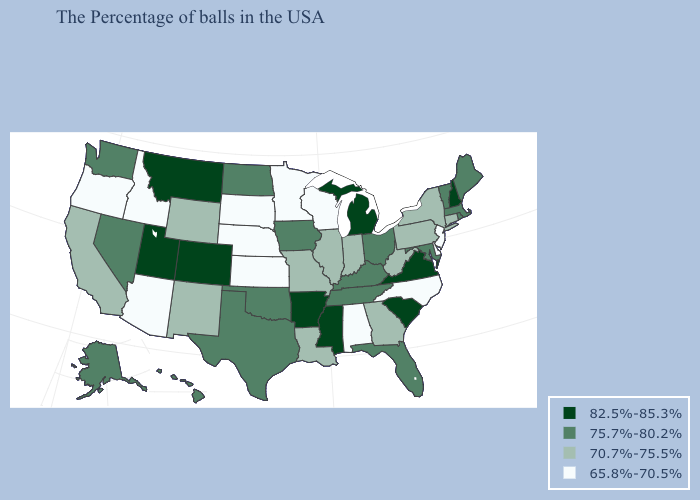Which states have the lowest value in the USA?
Quick response, please. New Jersey, Delaware, North Carolina, Alabama, Wisconsin, Minnesota, Kansas, Nebraska, South Dakota, Arizona, Idaho, Oregon. Is the legend a continuous bar?
Short answer required. No. What is the lowest value in states that border Nevada?
Short answer required. 65.8%-70.5%. Name the states that have a value in the range 75.7%-80.2%?
Give a very brief answer. Maine, Massachusetts, Rhode Island, Vermont, Maryland, Ohio, Florida, Kentucky, Tennessee, Iowa, Oklahoma, Texas, North Dakota, Nevada, Washington, Alaska, Hawaii. How many symbols are there in the legend?
Keep it brief. 4. Name the states that have a value in the range 75.7%-80.2%?
Be succinct. Maine, Massachusetts, Rhode Island, Vermont, Maryland, Ohio, Florida, Kentucky, Tennessee, Iowa, Oklahoma, Texas, North Dakota, Nevada, Washington, Alaska, Hawaii. What is the value of Alaska?
Write a very short answer. 75.7%-80.2%. Name the states that have a value in the range 75.7%-80.2%?
Write a very short answer. Maine, Massachusetts, Rhode Island, Vermont, Maryland, Ohio, Florida, Kentucky, Tennessee, Iowa, Oklahoma, Texas, North Dakota, Nevada, Washington, Alaska, Hawaii. Name the states that have a value in the range 75.7%-80.2%?
Concise answer only. Maine, Massachusetts, Rhode Island, Vermont, Maryland, Ohio, Florida, Kentucky, Tennessee, Iowa, Oklahoma, Texas, North Dakota, Nevada, Washington, Alaska, Hawaii. What is the value of Indiana?
Be succinct. 70.7%-75.5%. Which states have the lowest value in the USA?
Quick response, please. New Jersey, Delaware, North Carolina, Alabama, Wisconsin, Minnesota, Kansas, Nebraska, South Dakota, Arizona, Idaho, Oregon. Does Kentucky have a higher value than Tennessee?
Answer briefly. No. What is the lowest value in states that border Tennessee?
Concise answer only. 65.8%-70.5%. What is the value of Oregon?
Short answer required. 65.8%-70.5%. Name the states that have a value in the range 65.8%-70.5%?
Be succinct. New Jersey, Delaware, North Carolina, Alabama, Wisconsin, Minnesota, Kansas, Nebraska, South Dakota, Arizona, Idaho, Oregon. 